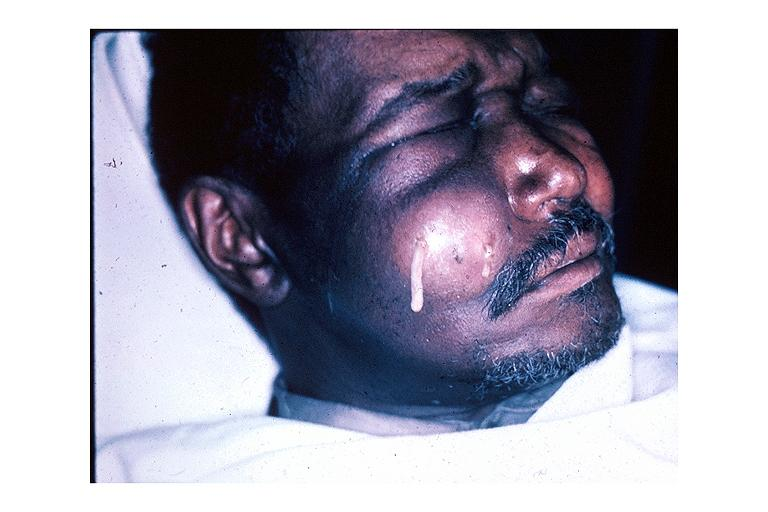does this image show facial abscess?
Answer the question using a single word or phrase. Yes 